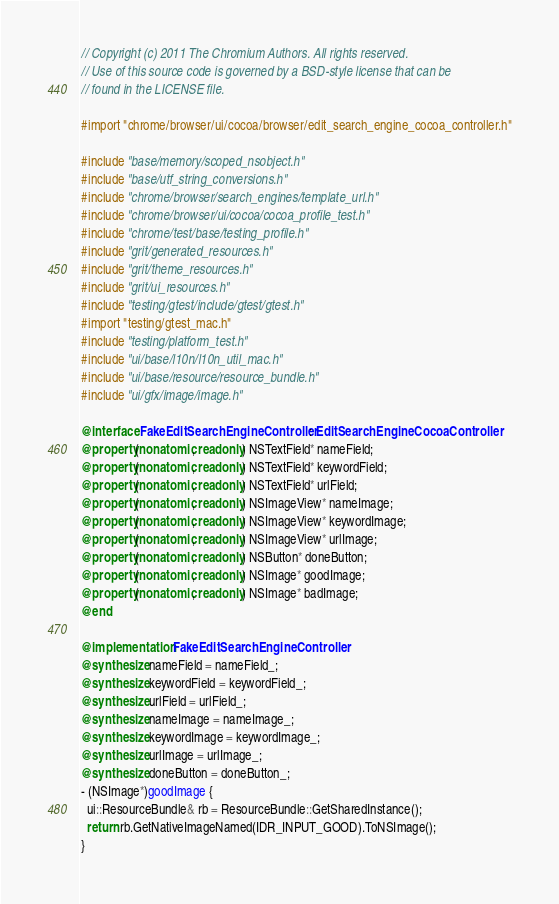<code> <loc_0><loc_0><loc_500><loc_500><_ObjectiveC_>// Copyright (c) 2011 The Chromium Authors. All rights reserved.
// Use of this source code is governed by a BSD-style license that can be
// found in the LICENSE file.

#import "chrome/browser/ui/cocoa/browser/edit_search_engine_cocoa_controller.h"

#include "base/memory/scoped_nsobject.h"
#include "base/utf_string_conversions.h"
#include "chrome/browser/search_engines/template_url.h"
#include "chrome/browser/ui/cocoa/cocoa_profile_test.h"
#include "chrome/test/base/testing_profile.h"
#include "grit/generated_resources.h"
#include "grit/theme_resources.h"
#include "grit/ui_resources.h"
#include "testing/gtest/include/gtest/gtest.h"
#import "testing/gtest_mac.h"
#include "testing/platform_test.h"
#include "ui/base/l10n/l10n_util_mac.h"
#include "ui/base/resource/resource_bundle.h"
#include "ui/gfx/image/image.h"

@interface FakeEditSearchEngineController : EditSearchEngineCocoaController
@property(nonatomic, readonly) NSTextField* nameField;
@property(nonatomic, readonly) NSTextField* keywordField;
@property(nonatomic, readonly) NSTextField* urlField;
@property(nonatomic, readonly) NSImageView* nameImage;
@property(nonatomic, readonly) NSImageView* keywordImage;
@property(nonatomic, readonly) NSImageView* urlImage;
@property(nonatomic, readonly) NSButton* doneButton;
@property(nonatomic, readonly) NSImage* goodImage;
@property(nonatomic, readonly) NSImage* badImage;
@end

@implementation FakeEditSearchEngineController
@synthesize nameField = nameField_;
@synthesize keywordField = keywordField_;
@synthesize urlField = urlField_;
@synthesize nameImage = nameImage_;
@synthesize keywordImage = keywordImage_;
@synthesize urlImage = urlImage_;
@synthesize doneButton = doneButton_;
- (NSImage*)goodImage {
  ui::ResourceBundle& rb = ResourceBundle::GetSharedInstance();
  return rb.GetNativeImageNamed(IDR_INPUT_GOOD).ToNSImage();
}</code> 